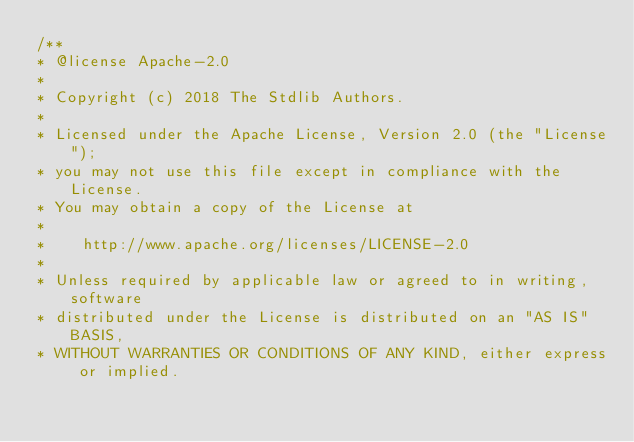<code> <loc_0><loc_0><loc_500><loc_500><_JavaScript_>/**
* @license Apache-2.0
*
* Copyright (c) 2018 The Stdlib Authors.
*
* Licensed under the Apache License, Version 2.0 (the "License");
* you may not use this file except in compliance with the License.
* You may obtain a copy of the License at
*
*    http://www.apache.org/licenses/LICENSE-2.0
*
* Unless required by applicable law or agreed to in writing, software
* distributed under the License is distributed on an "AS IS" BASIS,
* WITHOUT WARRANTIES OR CONDITIONS OF ANY KIND, either express or implied.</code> 